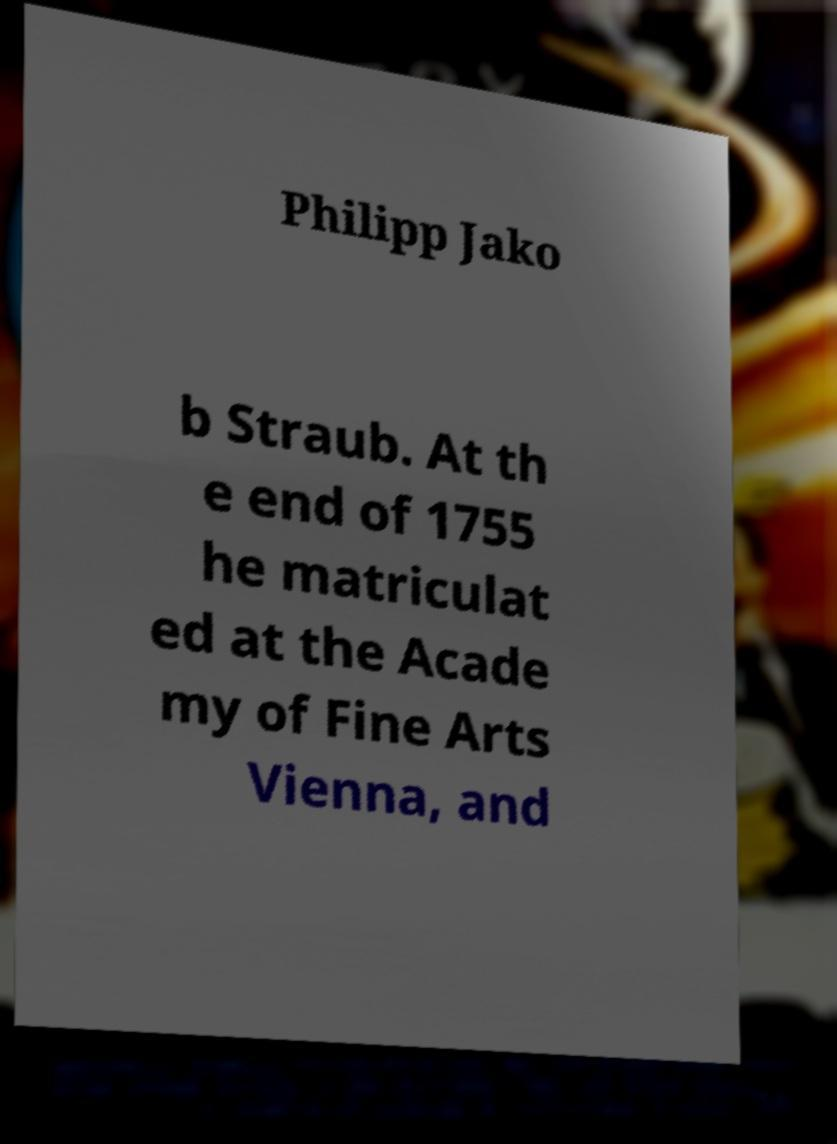Could you assist in decoding the text presented in this image and type it out clearly? Philipp Jako b Straub. At th e end of 1755 he matriculat ed at the Acade my of Fine Arts Vienna, and 